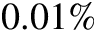Convert formula to latex. <formula><loc_0><loc_0><loc_500><loc_500>0 . 0 1 \%</formula> 